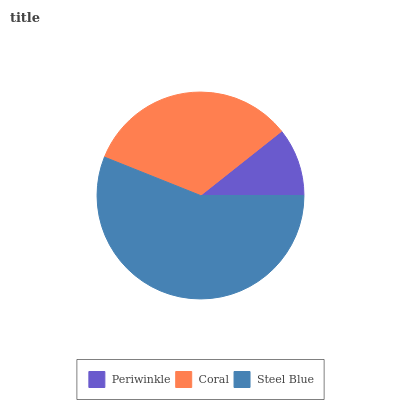Is Periwinkle the minimum?
Answer yes or no. Yes. Is Steel Blue the maximum?
Answer yes or no. Yes. Is Coral the minimum?
Answer yes or no. No. Is Coral the maximum?
Answer yes or no. No. Is Coral greater than Periwinkle?
Answer yes or no. Yes. Is Periwinkle less than Coral?
Answer yes or no. Yes. Is Periwinkle greater than Coral?
Answer yes or no. No. Is Coral less than Periwinkle?
Answer yes or no. No. Is Coral the high median?
Answer yes or no. Yes. Is Coral the low median?
Answer yes or no. Yes. Is Periwinkle the high median?
Answer yes or no. No. Is Periwinkle the low median?
Answer yes or no. No. 